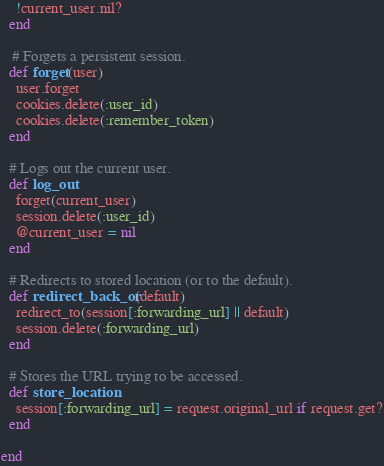<code> <loc_0><loc_0><loc_500><loc_500><_Ruby_>    !current_user.nil?
  end
  
   # Forgets a persistent session.
  def forget(user)
    user.forget
    cookies.delete(:user_id)
    cookies.delete(:remember_token)
  end
  
  # Logs out the current user.
  def log_out
    forget(current_user)
    session.delete(:user_id)
    @current_user = nil
  end
  
  # Redirects to stored location (or to the default).
  def redirect_back_or(default)
    redirect_to(session[:forwarding_url] || default)
    session.delete(:forwarding_url)
  end

  # Stores the URL trying to be accessed.
  def store_location
    session[:forwarding_url] = request.original_url if request.get?
  end

end
</code> 